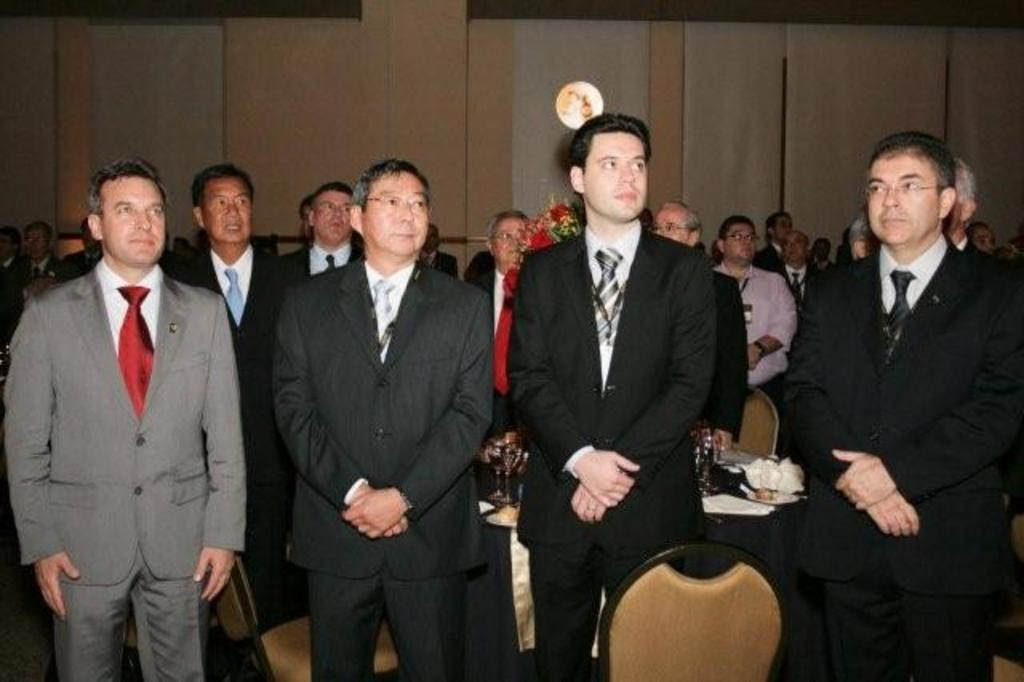What is happening in the image? There are people standing in the image. How can you describe the attire of the people? The people are wearing different color dresses. What furniture is present in the image? There are chairs in the image. What can be seen on the table in the image? There are objects on a table in the image. What is visible in the background of the image? There is a wall visible in the image. What type of toothpaste is being used by the people in the image? There is no toothpaste present in the image; the people are wearing different color dresses and standing. What kind of bushes can be seen growing near the wall in the image? There are no bushes visible in the image; only a wall is mentioned in the background. 